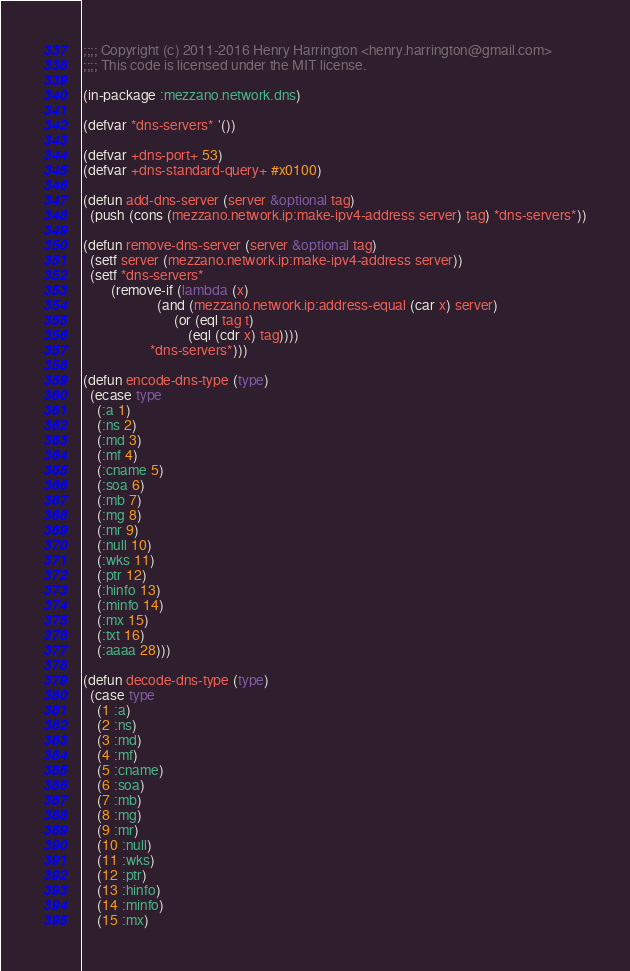<code> <loc_0><loc_0><loc_500><loc_500><_Lisp_>;;;; Copyright (c) 2011-2016 Henry Harrington <henry.harrington@gmail.com>
;;;; This code is licensed under the MIT license.

(in-package :mezzano.network.dns)

(defvar *dns-servers* '())

(defvar +dns-port+ 53)
(defvar +dns-standard-query+ #x0100)

(defun add-dns-server (server &optional tag)
  (push (cons (mezzano.network.ip:make-ipv4-address server) tag) *dns-servers*))

(defun remove-dns-server (server &optional tag)
  (setf server (mezzano.network.ip:make-ipv4-address server))
  (setf *dns-servers*
        (remove-if (lambda (x)
                     (and (mezzano.network.ip:address-equal (car x) server)
                          (or (eql tag t)
                              (eql (cdr x) tag))))
                   *dns-servers*)))

(defun encode-dns-type (type)
  (ecase type
    (:a 1)
    (:ns 2)
    (:md 3)
    (:mf 4)
    (:cname 5)
    (:soa 6)
    (:mb 7)
    (:mg 8)
    (:mr 9)
    (:null 10)
    (:wks 11)
    (:ptr 12)
    (:hinfo 13)
    (:minfo 14)
    (:mx 15)
    (:txt 16)
    (:aaaa 28)))

(defun decode-dns-type (type)
  (case type
    (1 :a)
    (2 :ns)
    (3 :md)
    (4 :mf)
    (5 :cname)
    (6 :soa)
    (7 :mb)
    (8 :mg)
    (9 :mr)
    (10 :null)
    (11 :wks)
    (12 :ptr)
    (13 :hinfo)
    (14 :minfo)
    (15 :mx)</code> 